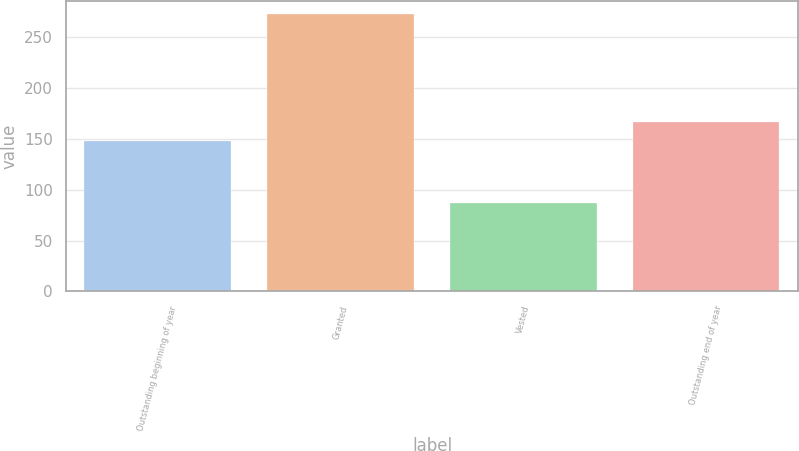Convert chart. <chart><loc_0><loc_0><loc_500><loc_500><bar_chart><fcel>Outstanding beginning of year<fcel>Granted<fcel>Vested<fcel>Outstanding end of year<nl><fcel>148.22<fcel>272.28<fcel>87.36<fcel>166.71<nl></chart> 